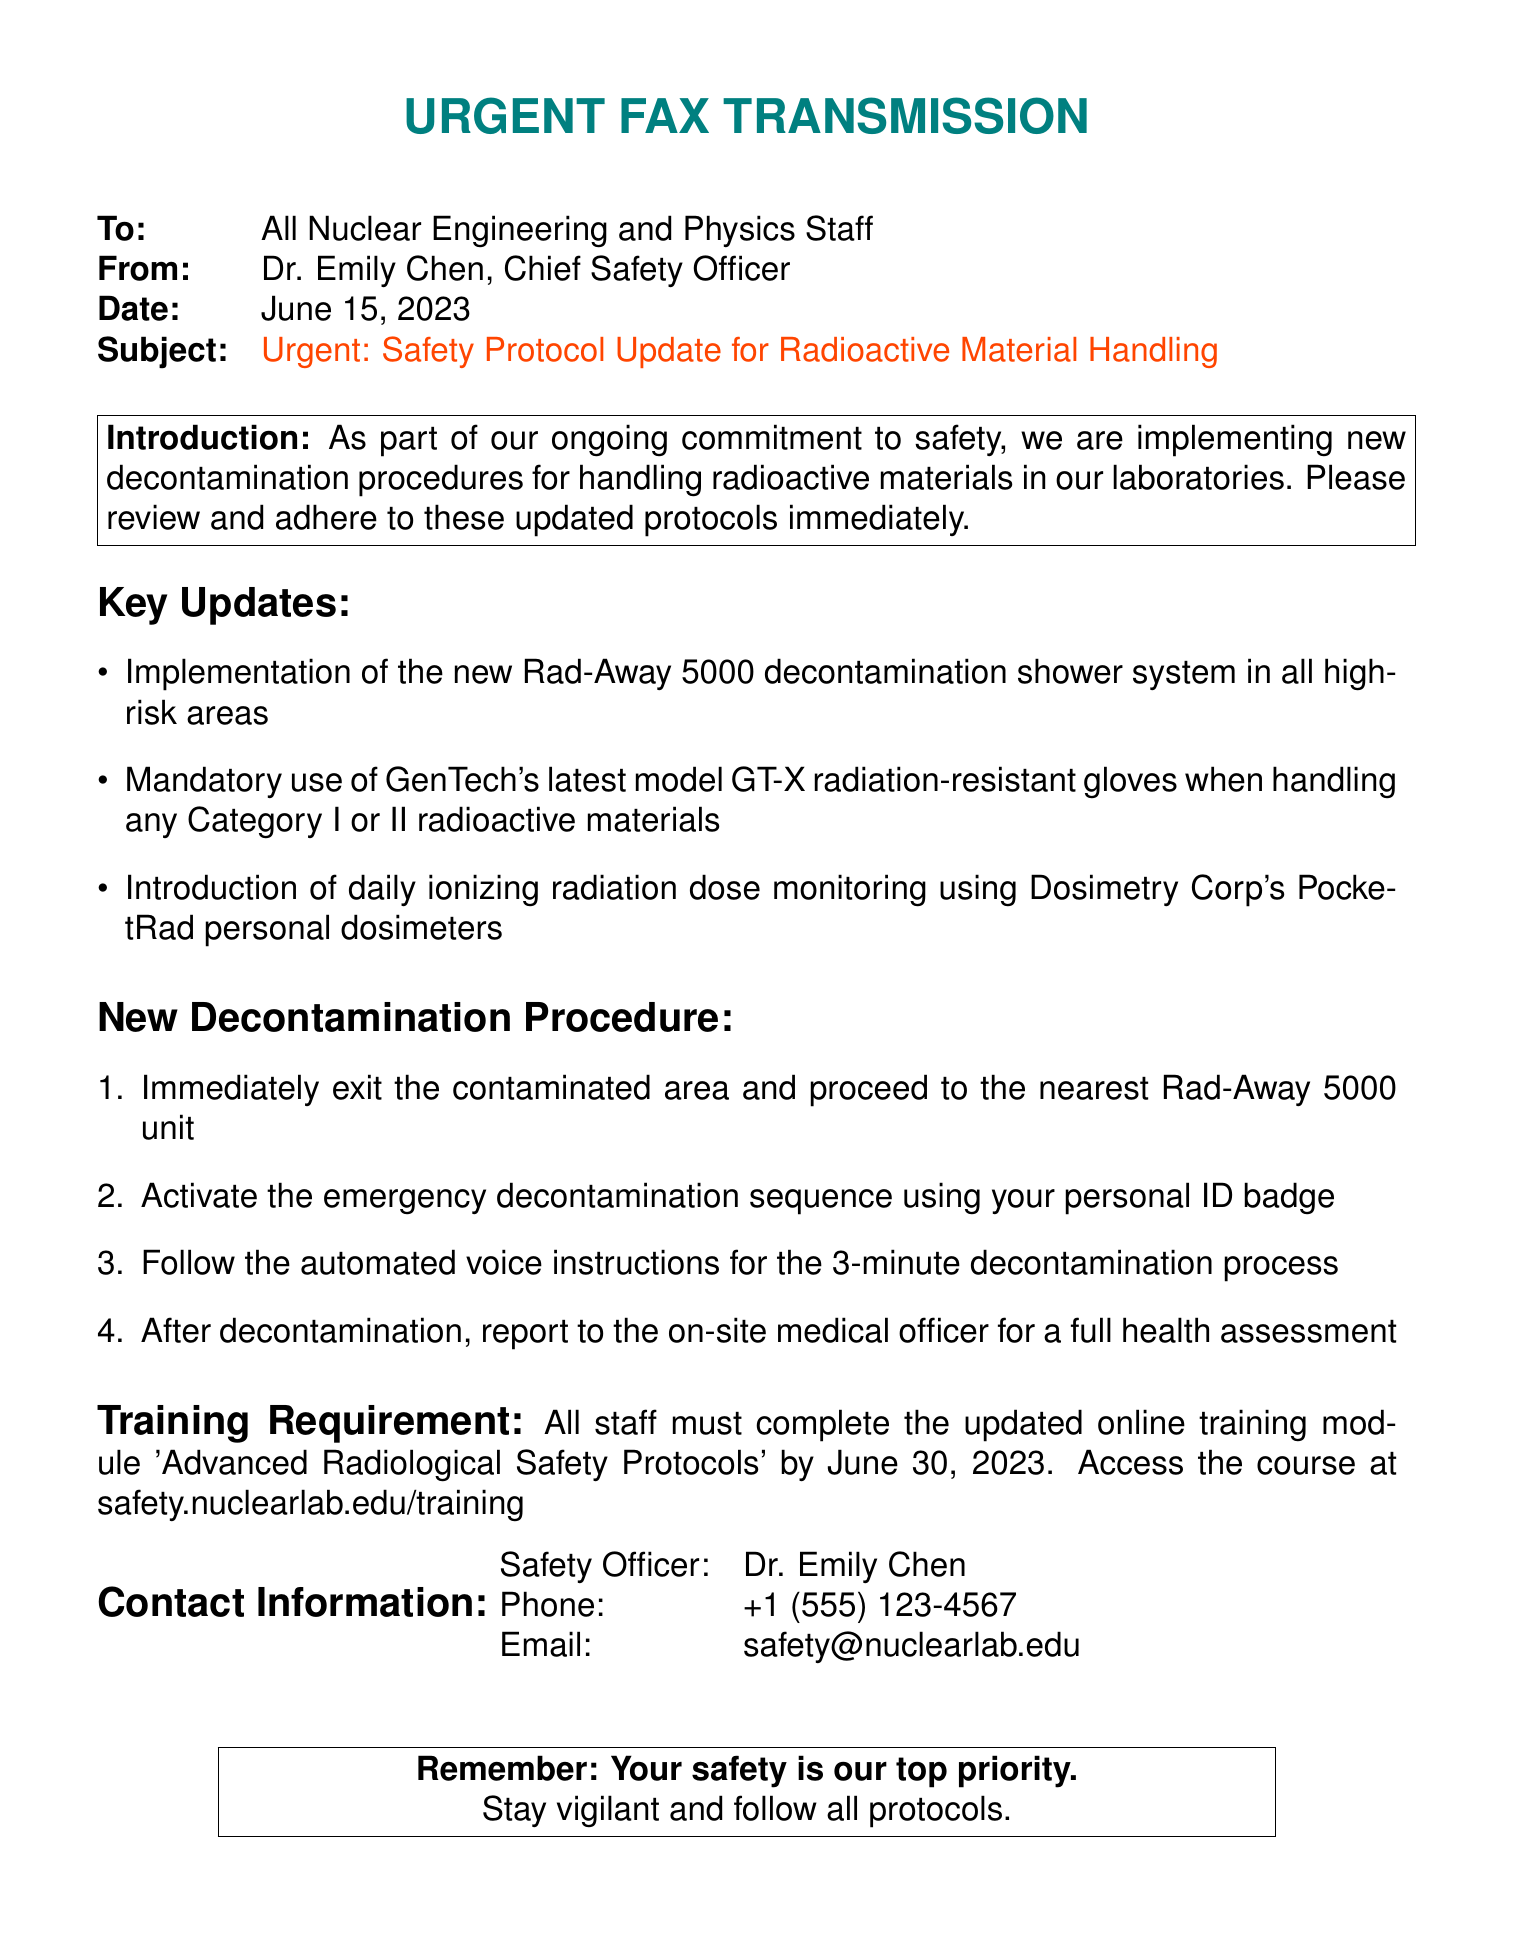What is the subject of the fax? The subject of the fax is clearly stated as "Urgent: Safety Protocol Update for Radioactive Material Handling."
Answer: Urgent: Safety Protocol Update for Radioactive Material Handling Who sent the fax? The sender is identified as Dr. Emily Chen, Chief Safety Officer.
Answer: Dr. Emily Chen What is the date of the fax? The date specified in the fax is June 15, 2023.
Answer: June 15, 2023 What is the name of the decontamination shower system mentioned? The decontamination shower system is referred to as the "Rad-Away 5000."
Answer: Rad-Away 5000 What must staff complete by June 30, 2023? Staff must complete the updated online training module "Advanced Radiological Safety Protocols."
Answer: Advanced Radiological Safety Protocols What is the purpose of the PocketRad personal dosimeters? The purpose of the dosimeters is for daily ionizing radiation dose monitoring.
Answer: Daily ionizing radiation dose monitoring What is the first step in the new decontamination procedure? The first step is to "Immediately exit the contaminated area and proceed to the nearest Rad-Away 5000 unit."
Answer: Immediately exit the contaminated area and proceed to the nearest Rad-Away 5000 unit What is the recommended action after decontamination? After decontamination, the recommended action is to report to the on-site medical officer for a full health assessment.
Answer: Report to the on-site medical officer for a full health assessment How many minutes does the decontamination process take? The decontamination process is indicated to take three minutes.
Answer: 3 minutes 